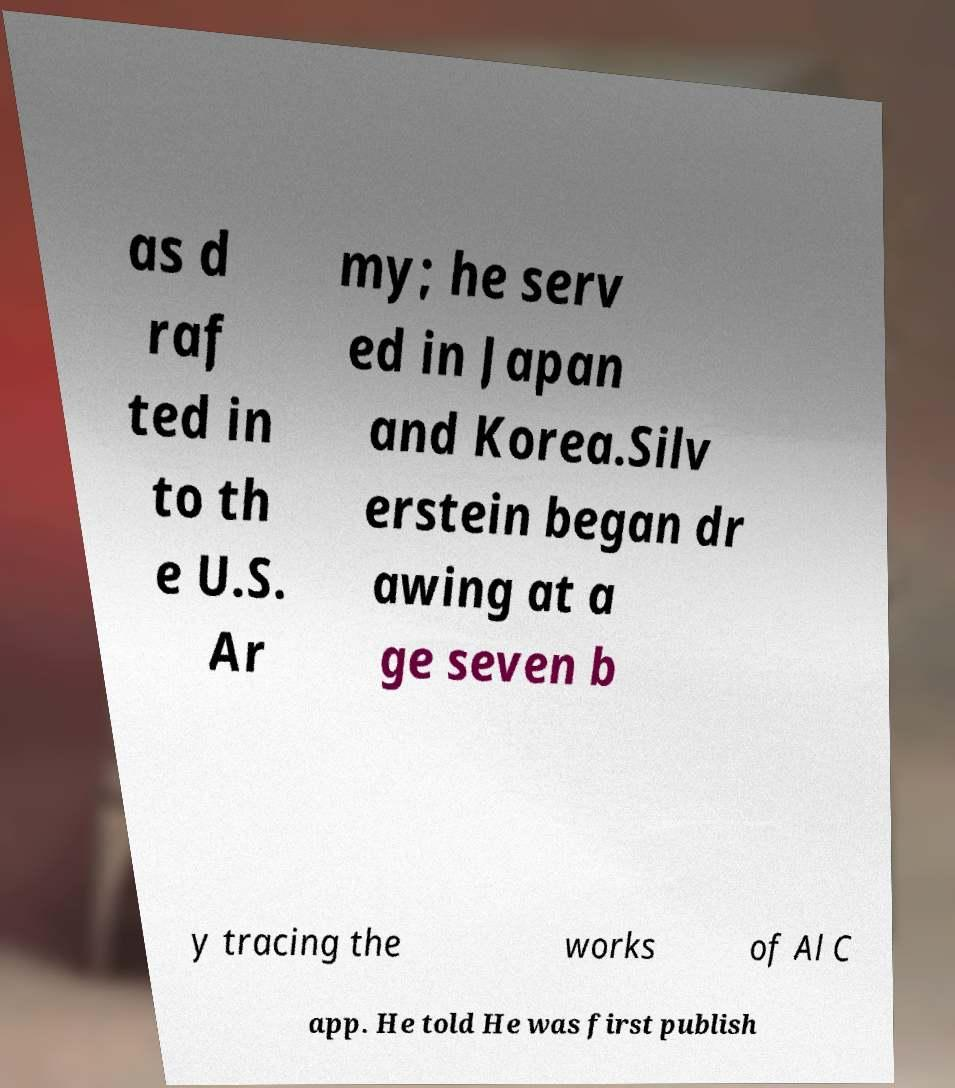Can you read and provide the text displayed in the image?This photo seems to have some interesting text. Can you extract and type it out for me? as d raf ted in to th e U.S. Ar my; he serv ed in Japan and Korea.Silv erstein began dr awing at a ge seven b y tracing the works of Al C app. He told He was first publish 